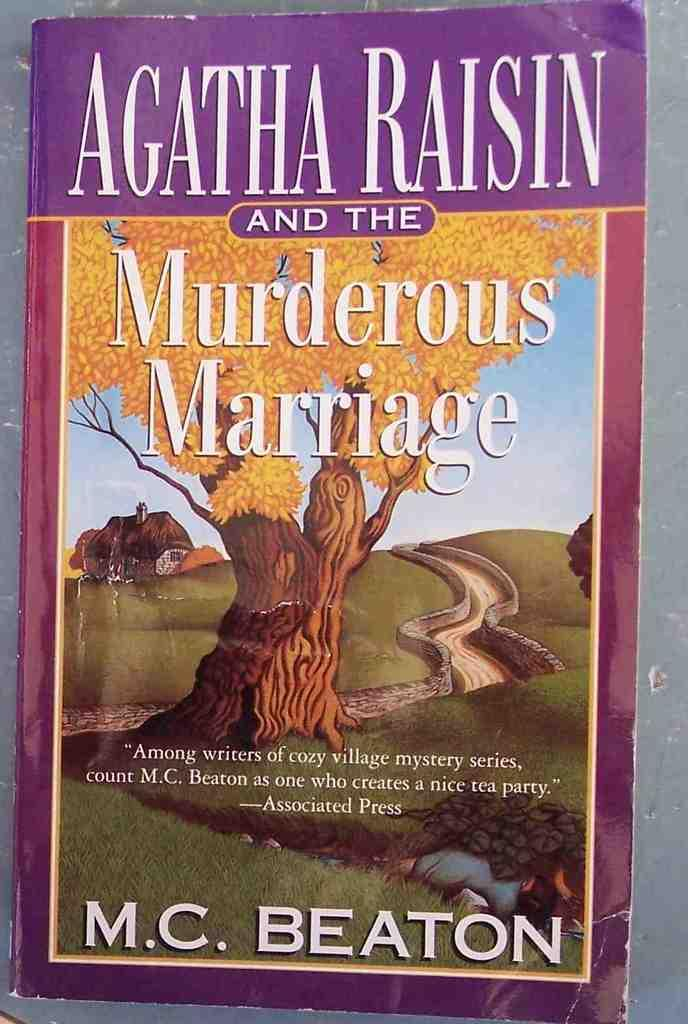<image>
Create a compact narrative representing the image presented. A book by M.C. Beaton features a tree in autumn foliage on the cover. 